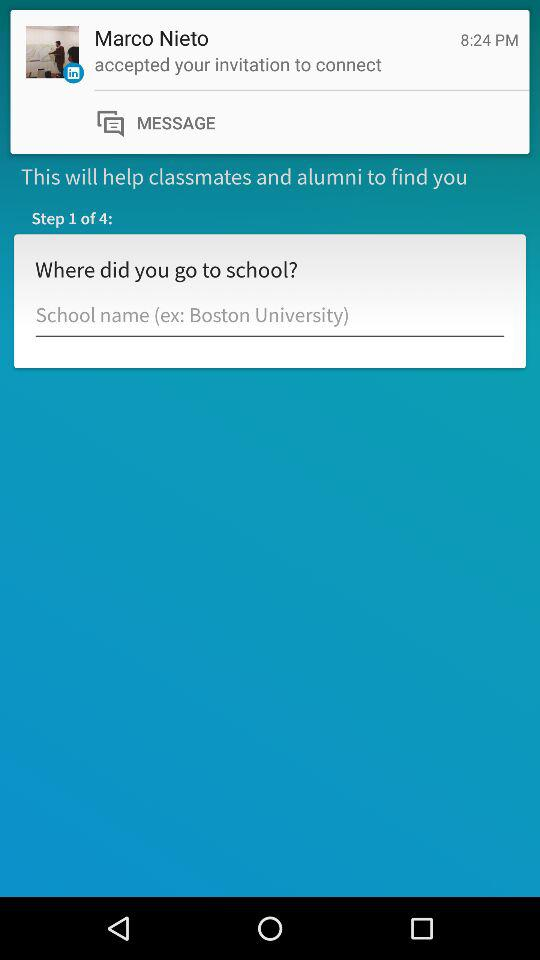How many steps in total are there? There are 4 steps in total. 